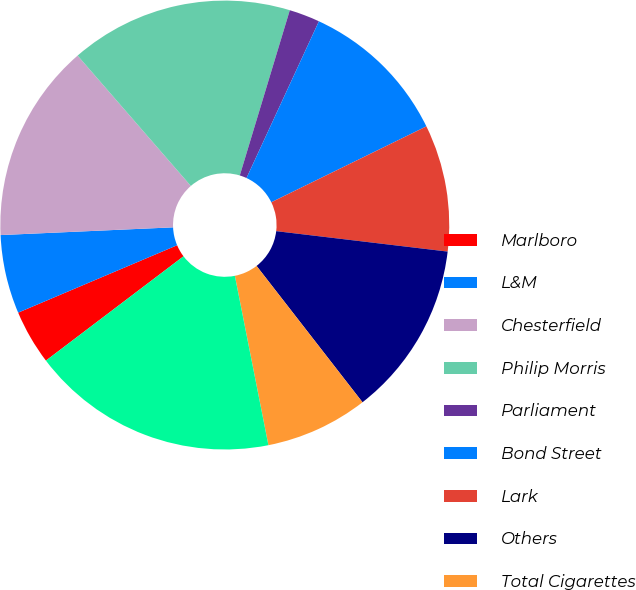Convert chart. <chart><loc_0><loc_0><loc_500><loc_500><pie_chart><fcel>Marlboro<fcel>L&M<fcel>Chesterfield<fcel>Philip Morris<fcel>Parliament<fcel>Bond Street<fcel>Lark<fcel>Others<fcel>Total Cigarettes<fcel>Heated Tobacco Units<nl><fcel>3.94%<fcel>5.67%<fcel>14.33%<fcel>16.06%<fcel>2.21%<fcel>10.87%<fcel>9.13%<fcel>12.6%<fcel>7.4%<fcel>17.79%<nl></chart> 